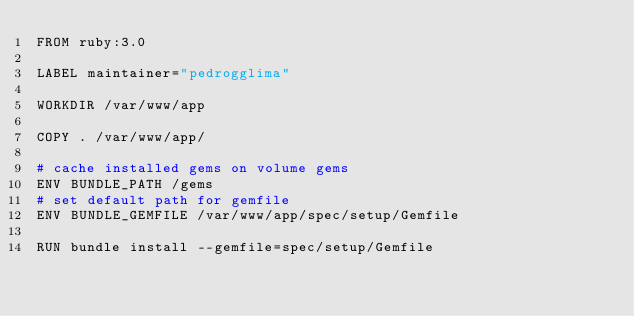Convert code to text. <code><loc_0><loc_0><loc_500><loc_500><_Dockerfile_>FROM ruby:3.0

LABEL maintainer="pedrogglima"

WORKDIR /var/www/app

COPY . /var/www/app/

# cache installed gems on volume gems
ENV BUNDLE_PATH /gems
# set default path for gemfile 
ENV BUNDLE_GEMFILE /var/www/app/spec/setup/Gemfile

RUN bundle install --gemfile=spec/setup/Gemfile
</code> 